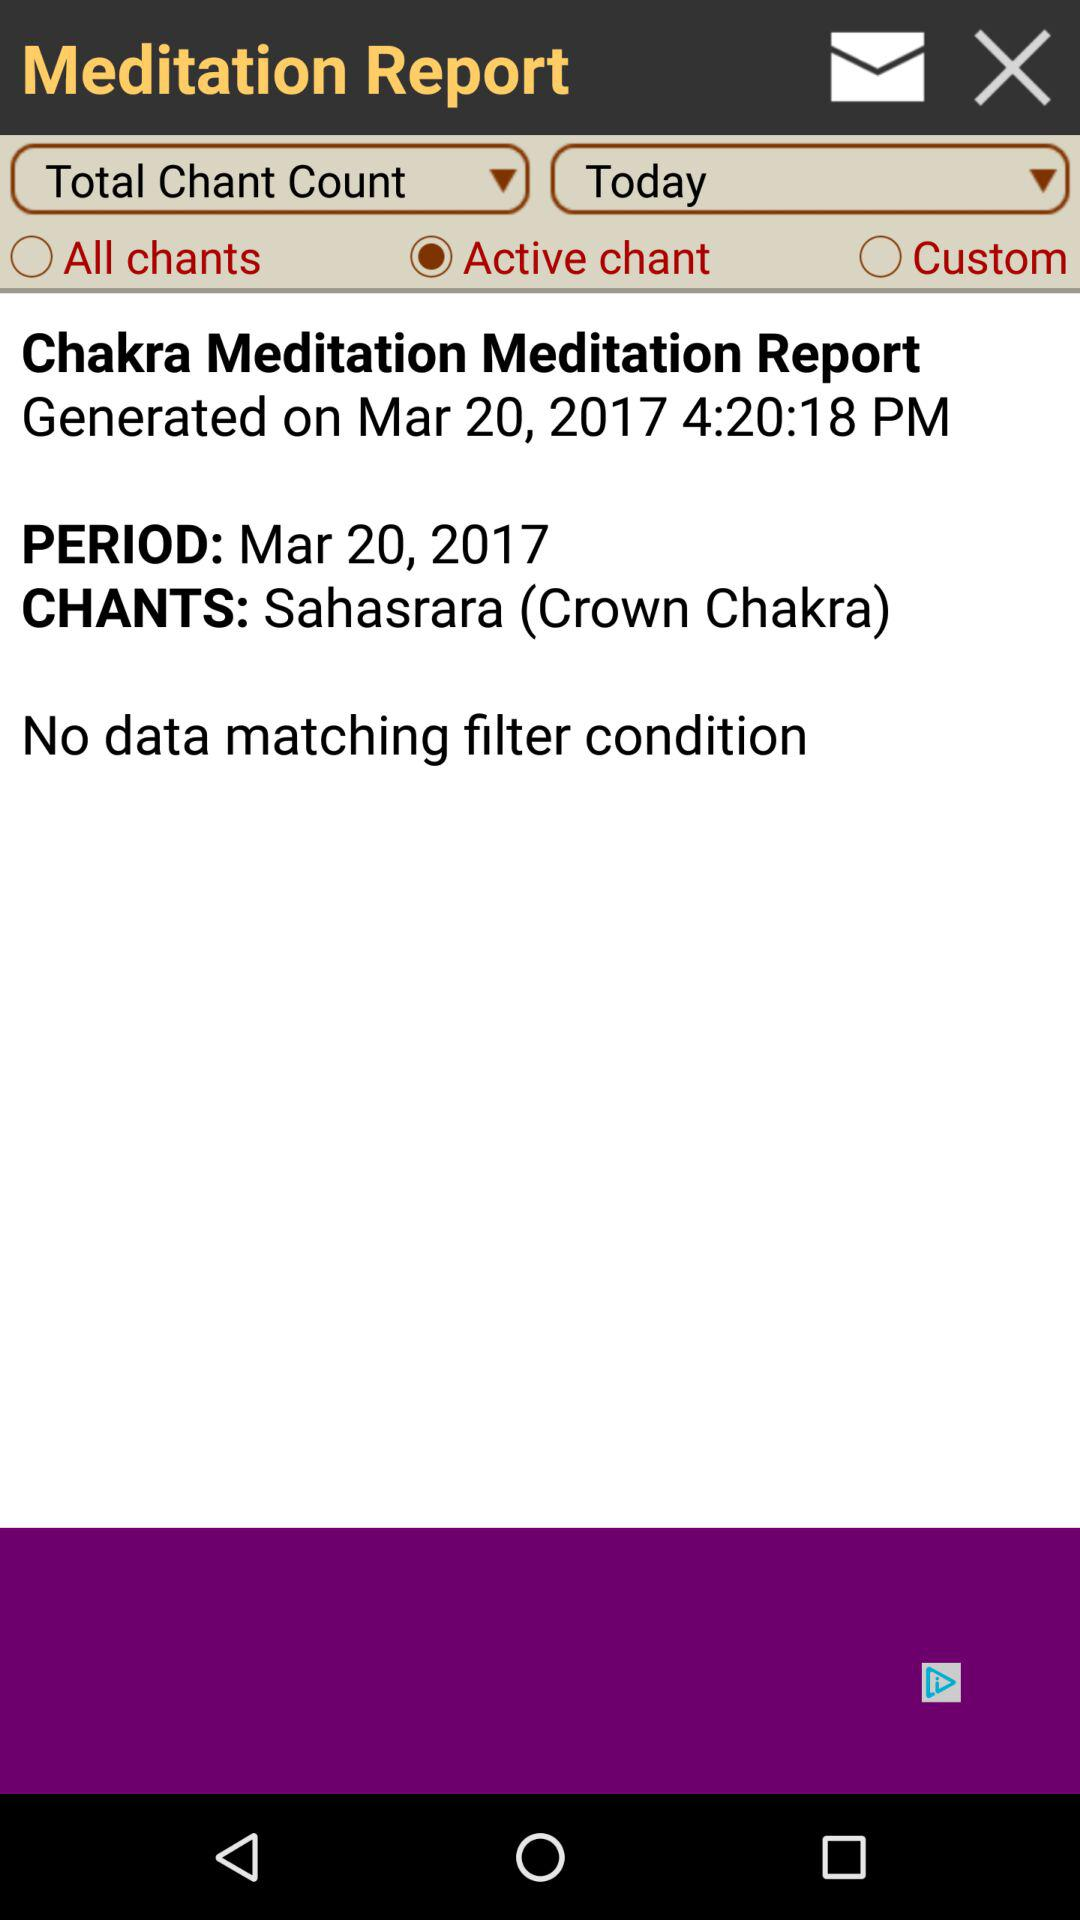At what time does the Chakra Meditation Report get generated? The report was generated at 4:20:18 PM. 